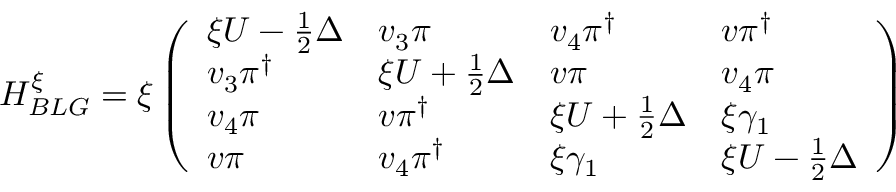<formula> <loc_0><loc_0><loc_500><loc_500>H _ { B L G } ^ { \xi } = \xi \left ( \begin{array} { l l l l } { \xi U - \frac { 1 } { 2 } \Delta } & { v _ { 3 } \pi } & { v _ { 4 } \pi ^ { \dagger } } & { v \pi ^ { \dagger } } \\ { v _ { 3 } \pi ^ { \dagger } } & { \xi U + \frac { 1 } { 2 } \Delta } & { v \pi } & { v _ { 4 } \pi } \\ { v _ { 4 } \pi } & { v \pi ^ { \dagger } } & { \xi U + \frac { 1 } { 2 } \Delta } & { \xi \gamma _ { 1 } } \\ { v \pi } & { v _ { 4 } \pi ^ { \dagger } } & { \xi \gamma _ { 1 } } & { \xi U - \frac { 1 } { 2 } \Delta } \end{array} \right )</formula> 